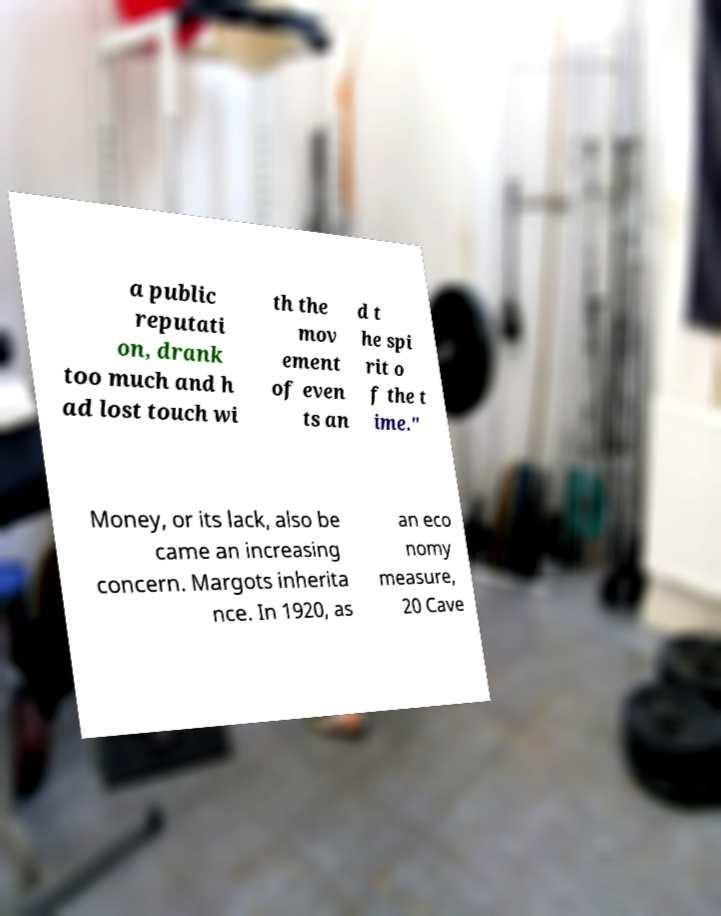What messages or text are displayed in this image? I need them in a readable, typed format. a public reputati on, drank too much and h ad lost touch wi th the mov ement of even ts an d t he spi rit o f the t ime." Money, or its lack, also be came an increasing concern. Margots inherita nce. In 1920, as an eco nomy measure, 20 Cave 